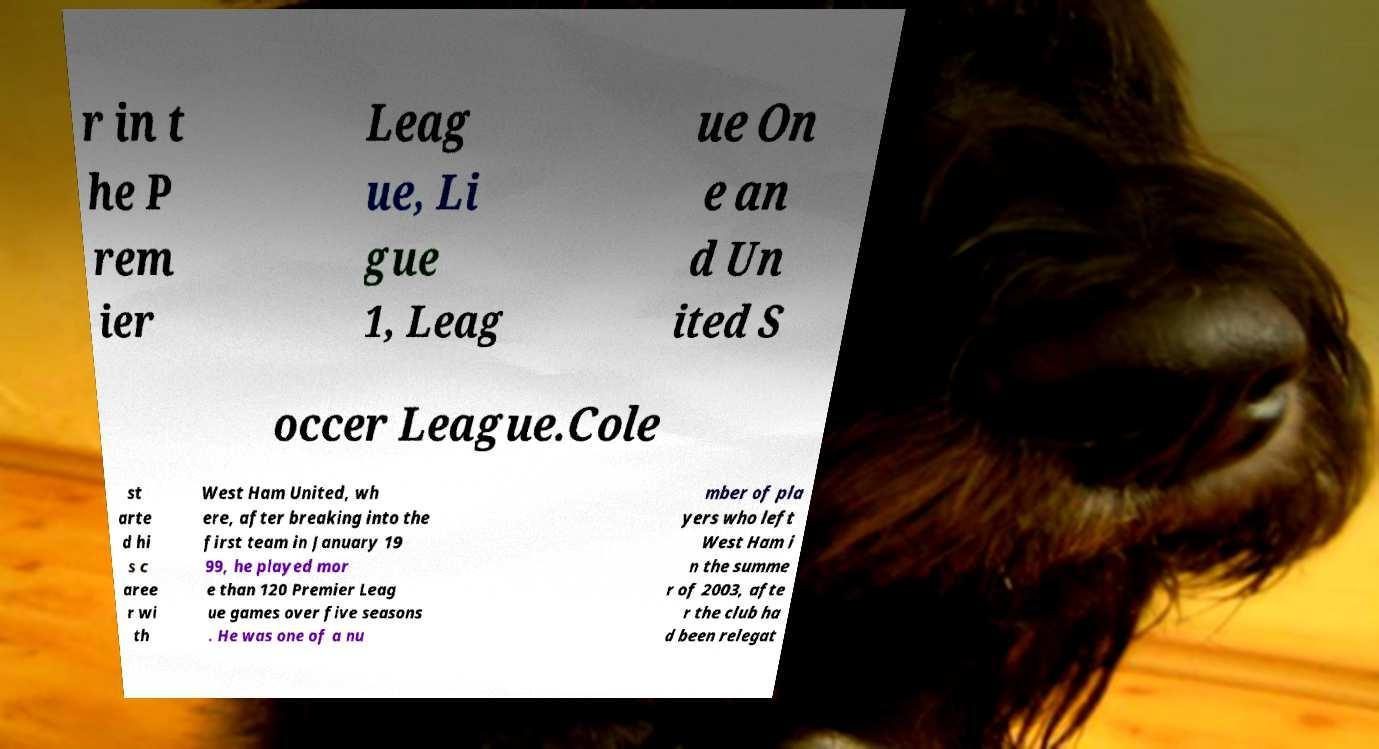I need the written content from this picture converted into text. Can you do that? r in t he P rem ier Leag ue, Li gue 1, Leag ue On e an d Un ited S occer League.Cole st arte d hi s c aree r wi th West Ham United, wh ere, after breaking into the first team in January 19 99, he played mor e than 120 Premier Leag ue games over five seasons . He was one of a nu mber of pla yers who left West Ham i n the summe r of 2003, afte r the club ha d been relegat 